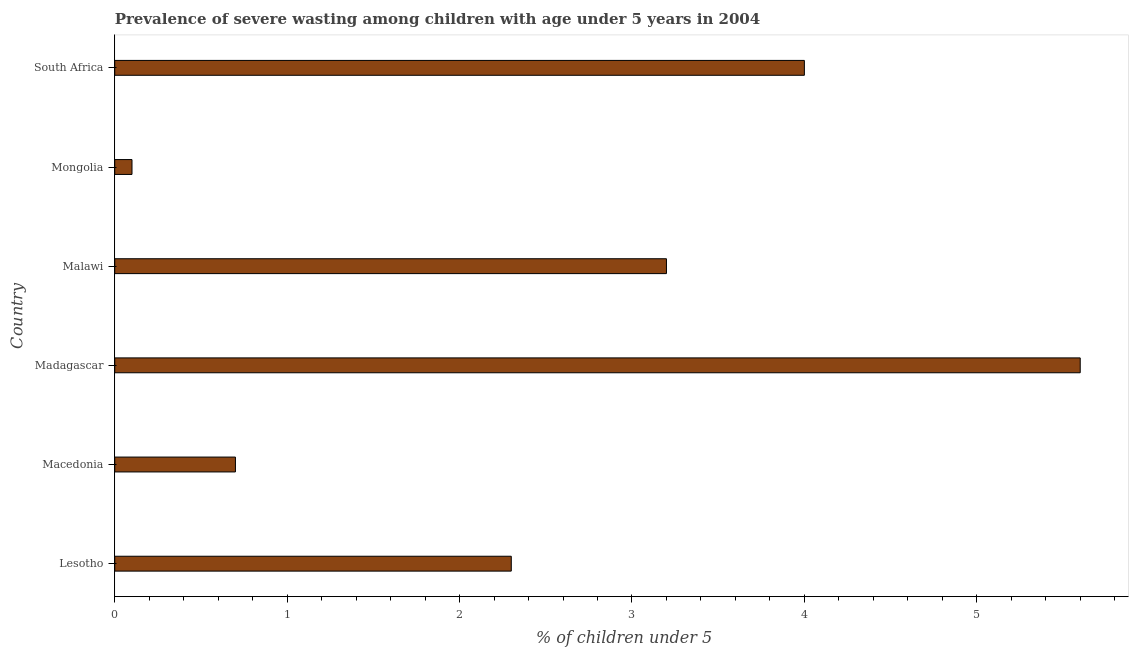Does the graph contain any zero values?
Your response must be concise. No. What is the title of the graph?
Your response must be concise. Prevalence of severe wasting among children with age under 5 years in 2004. What is the label or title of the X-axis?
Your answer should be very brief.  % of children under 5. What is the label or title of the Y-axis?
Make the answer very short. Country. What is the prevalence of severe wasting in Lesotho?
Provide a succinct answer. 2.3. Across all countries, what is the maximum prevalence of severe wasting?
Your answer should be compact. 5.6. Across all countries, what is the minimum prevalence of severe wasting?
Provide a short and direct response. 0.1. In which country was the prevalence of severe wasting maximum?
Your answer should be very brief. Madagascar. In which country was the prevalence of severe wasting minimum?
Your answer should be compact. Mongolia. What is the sum of the prevalence of severe wasting?
Provide a short and direct response. 15.9. What is the difference between the prevalence of severe wasting in Lesotho and South Africa?
Your response must be concise. -1.7. What is the average prevalence of severe wasting per country?
Make the answer very short. 2.65. What is the median prevalence of severe wasting?
Provide a short and direct response. 2.75. What is the ratio of the prevalence of severe wasting in Mongolia to that in South Africa?
Provide a succinct answer. 0.03. Is the difference between the prevalence of severe wasting in Madagascar and South Africa greater than the difference between any two countries?
Your answer should be compact. No. How many bars are there?
Offer a terse response. 6. Are all the bars in the graph horizontal?
Give a very brief answer. Yes. How many countries are there in the graph?
Make the answer very short. 6. What is the difference between two consecutive major ticks on the X-axis?
Your answer should be compact. 1. Are the values on the major ticks of X-axis written in scientific E-notation?
Offer a very short reply. No. What is the  % of children under 5 of Lesotho?
Ensure brevity in your answer.  2.3. What is the  % of children under 5 of Madagascar?
Your response must be concise. 5.6. What is the  % of children under 5 in Malawi?
Give a very brief answer. 3.2. What is the  % of children under 5 in Mongolia?
Ensure brevity in your answer.  0.1. What is the  % of children under 5 in South Africa?
Keep it short and to the point. 4. What is the difference between the  % of children under 5 in Lesotho and Macedonia?
Your answer should be compact. 1.6. What is the difference between the  % of children under 5 in Lesotho and Madagascar?
Ensure brevity in your answer.  -3.3. What is the difference between the  % of children under 5 in Lesotho and Malawi?
Give a very brief answer. -0.9. What is the difference between the  % of children under 5 in Lesotho and South Africa?
Offer a terse response. -1.7. What is the difference between the  % of children under 5 in Macedonia and Mongolia?
Your response must be concise. 0.6. What is the difference between the  % of children under 5 in Macedonia and South Africa?
Give a very brief answer. -3.3. What is the difference between the  % of children under 5 in Madagascar and Malawi?
Offer a terse response. 2.4. What is the difference between the  % of children under 5 in Madagascar and Mongolia?
Your answer should be very brief. 5.5. What is the difference between the  % of children under 5 in Madagascar and South Africa?
Offer a terse response. 1.6. What is the difference between the  % of children under 5 in Malawi and Mongolia?
Keep it short and to the point. 3.1. What is the difference between the  % of children under 5 in Malawi and South Africa?
Provide a succinct answer. -0.8. What is the difference between the  % of children under 5 in Mongolia and South Africa?
Offer a terse response. -3.9. What is the ratio of the  % of children under 5 in Lesotho to that in Macedonia?
Provide a short and direct response. 3.29. What is the ratio of the  % of children under 5 in Lesotho to that in Madagascar?
Your response must be concise. 0.41. What is the ratio of the  % of children under 5 in Lesotho to that in Malawi?
Offer a very short reply. 0.72. What is the ratio of the  % of children under 5 in Lesotho to that in South Africa?
Give a very brief answer. 0.57. What is the ratio of the  % of children under 5 in Macedonia to that in Malawi?
Offer a very short reply. 0.22. What is the ratio of the  % of children under 5 in Macedonia to that in South Africa?
Ensure brevity in your answer.  0.17. What is the ratio of the  % of children under 5 in Malawi to that in South Africa?
Ensure brevity in your answer.  0.8. What is the ratio of the  % of children under 5 in Mongolia to that in South Africa?
Offer a very short reply. 0.03. 